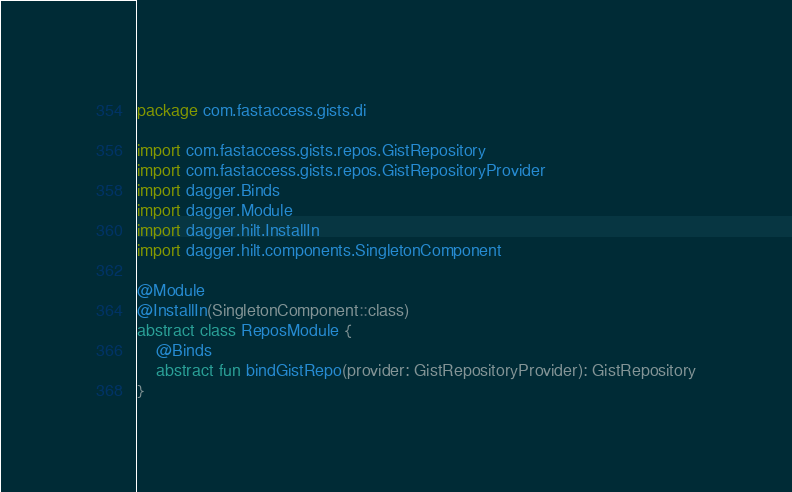<code> <loc_0><loc_0><loc_500><loc_500><_Kotlin_>package com.fastaccess.gists.di

import com.fastaccess.gists.repos.GistRepository
import com.fastaccess.gists.repos.GistRepositoryProvider
import dagger.Binds
import dagger.Module
import dagger.hilt.InstallIn
import dagger.hilt.components.SingletonComponent

@Module
@InstallIn(SingletonComponent::class)
abstract class ReposModule {
    @Binds
    abstract fun bindGistRepo(provider: GistRepositoryProvider): GistRepository
}</code> 